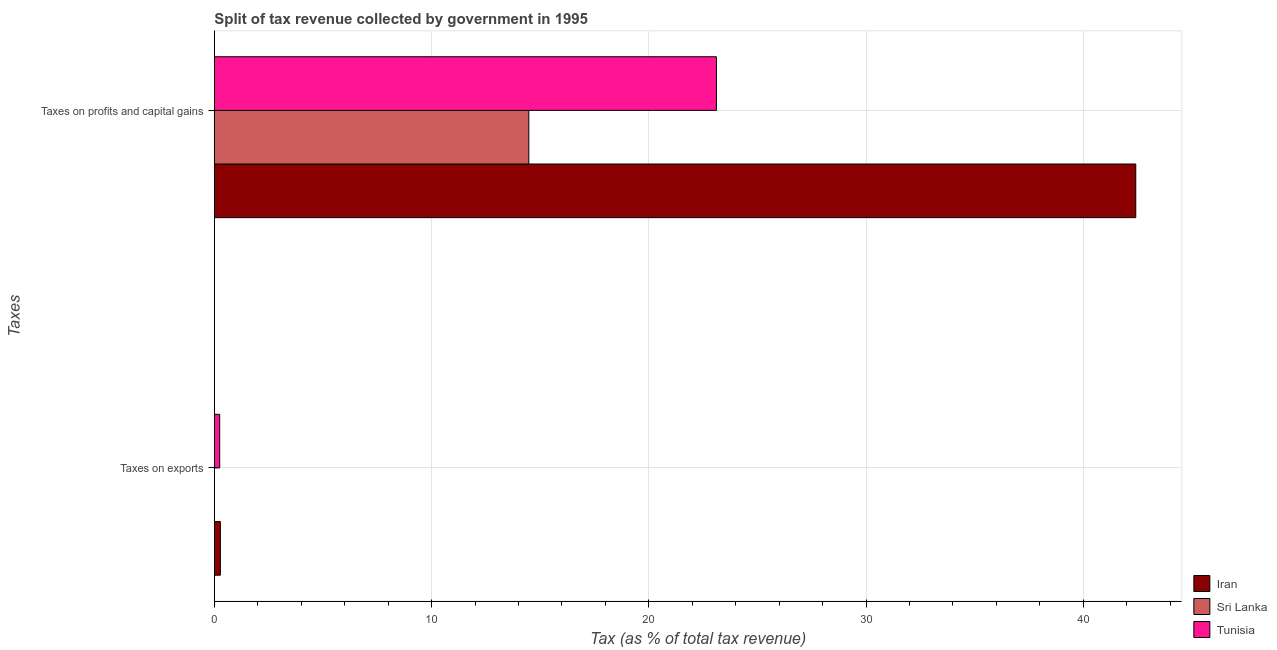Are the number of bars on each tick of the Y-axis equal?
Your answer should be very brief. Yes. How many bars are there on the 1st tick from the bottom?
Your answer should be compact. 3. What is the label of the 1st group of bars from the top?
Provide a succinct answer. Taxes on profits and capital gains. What is the percentage of revenue obtained from taxes on exports in Iran?
Your response must be concise. 0.28. Across all countries, what is the maximum percentage of revenue obtained from taxes on profits and capital gains?
Your answer should be compact. 42.42. Across all countries, what is the minimum percentage of revenue obtained from taxes on profits and capital gains?
Keep it short and to the point. 14.48. In which country was the percentage of revenue obtained from taxes on exports maximum?
Make the answer very short. Iran. In which country was the percentage of revenue obtained from taxes on profits and capital gains minimum?
Ensure brevity in your answer.  Sri Lanka. What is the total percentage of revenue obtained from taxes on exports in the graph?
Make the answer very short. 0.53. What is the difference between the percentage of revenue obtained from taxes on exports in Iran and that in Tunisia?
Make the answer very short. 0.03. What is the difference between the percentage of revenue obtained from taxes on profits and capital gains in Sri Lanka and the percentage of revenue obtained from taxes on exports in Tunisia?
Your answer should be compact. 14.23. What is the average percentage of revenue obtained from taxes on exports per country?
Keep it short and to the point. 0.18. What is the difference between the percentage of revenue obtained from taxes on profits and capital gains and percentage of revenue obtained from taxes on exports in Iran?
Ensure brevity in your answer.  42.14. What is the ratio of the percentage of revenue obtained from taxes on profits and capital gains in Tunisia to that in Sri Lanka?
Your answer should be compact. 1.6. In how many countries, is the percentage of revenue obtained from taxes on profits and capital gains greater than the average percentage of revenue obtained from taxes on profits and capital gains taken over all countries?
Offer a terse response. 1. What does the 3rd bar from the top in Taxes on profits and capital gains represents?
Provide a succinct answer. Iran. What does the 2nd bar from the bottom in Taxes on profits and capital gains represents?
Give a very brief answer. Sri Lanka. How many bars are there?
Give a very brief answer. 6. How many countries are there in the graph?
Provide a succinct answer. 3. Are the values on the major ticks of X-axis written in scientific E-notation?
Give a very brief answer. No. Does the graph contain any zero values?
Keep it short and to the point. No. Does the graph contain grids?
Give a very brief answer. Yes. How many legend labels are there?
Keep it short and to the point. 3. What is the title of the graph?
Provide a succinct answer. Split of tax revenue collected by government in 1995. Does "Heavily indebted poor countries" appear as one of the legend labels in the graph?
Your response must be concise. No. What is the label or title of the X-axis?
Give a very brief answer. Tax (as % of total tax revenue). What is the label or title of the Y-axis?
Keep it short and to the point. Taxes. What is the Tax (as % of total tax revenue) of Iran in Taxes on exports?
Your response must be concise. 0.28. What is the Tax (as % of total tax revenue) of Sri Lanka in Taxes on exports?
Keep it short and to the point. 0.01. What is the Tax (as % of total tax revenue) of Tunisia in Taxes on exports?
Make the answer very short. 0.25. What is the Tax (as % of total tax revenue) of Iran in Taxes on profits and capital gains?
Provide a short and direct response. 42.42. What is the Tax (as % of total tax revenue) of Sri Lanka in Taxes on profits and capital gains?
Offer a very short reply. 14.48. What is the Tax (as % of total tax revenue) in Tunisia in Taxes on profits and capital gains?
Provide a succinct answer. 23.11. Across all Taxes, what is the maximum Tax (as % of total tax revenue) of Iran?
Offer a terse response. 42.42. Across all Taxes, what is the maximum Tax (as % of total tax revenue) of Sri Lanka?
Give a very brief answer. 14.48. Across all Taxes, what is the maximum Tax (as % of total tax revenue) of Tunisia?
Your answer should be very brief. 23.11. Across all Taxes, what is the minimum Tax (as % of total tax revenue) of Iran?
Provide a short and direct response. 0.28. Across all Taxes, what is the minimum Tax (as % of total tax revenue) in Sri Lanka?
Offer a terse response. 0.01. Across all Taxes, what is the minimum Tax (as % of total tax revenue) in Tunisia?
Your answer should be very brief. 0.25. What is the total Tax (as % of total tax revenue) of Iran in the graph?
Give a very brief answer. 42.69. What is the total Tax (as % of total tax revenue) of Sri Lanka in the graph?
Provide a short and direct response. 14.48. What is the total Tax (as % of total tax revenue) in Tunisia in the graph?
Your answer should be very brief. 23.36. What is the difference between the Tax (as % of total tax revenue) in Iran in Taxes on exports and that in Taxes on profits and capital gains?
Your response must be concise. -42.14. What is the difference between the Tax (as % of total tax revenue) of Sri Lanka in Taxes on exports and that in Taxes on profits and capital gains?
Ensure brevity in your answer.  -14.47. What is the difference between the Tax (as % of total tax revenue) in Tunisia in Taxes on exports and that in Taxes on profits and capital gains?
Provide a short and direct response. -22.87. What is the difference between the Tax (as % of total tax revenue) of Iran in Taxes on exports and the Tax (as % of total tax revenue) of Sri Lanka in Taxes on profits and capital gains?
Provide a short and direct response. -14.2. What is the difference between the Tax (as % of total tax revenue) in Iran in Taxes on exports and the Tax (as % of total tax revenue) in Tunisia in Taxes on profits and capital gains?
Your answer should be compact. -22.84. What is the difference between the Tax (as % of total tax revenue) in Sri Lanka in Taxes on exports and the Tax (as % of total tax revenue) in Tunisia in Taxes on profits and capital gains?
Keep it short and to the point. -23.11. What is the average Tax (as % of total tax revenue) in Iran per Taxes?
Your answer should be very brief. 21.35. What is the average Tax (as % of total tax revenue) of Sri Lanka per Taxes?
Ensure brevity in your answer.  7.24. What is the average Tax (as % of total tax revenue) of Tunisia per Taxes?
Your answer should be very brief. 11.68. What is the difference between the Tax (as % of total tax revenue) of Iran and Tax (as % of total tax revenue) of Sri Lanka in Taxes on exports?
Give a very brief answer. 0.27. What is the difference between the Tax (as % of total tax revenue) in Iran and Tax (as % of total tax revenue) in Tunisia in Taxes on exports?
Provide a short and direct response. 0.03. What is the difference between the Tax (as % of total tax revenue) in Sri Lanka and Tax (as % of total tax revenue) in Tunisia in Taxes on exports?
Give a very brief answer. -0.24. What is the difference between the Tax (as % of total tax revenue) of Iran and Tax (as % of total tax revenue) of Sri Lanka in Taxes on profits and capital gains?
Give a very brief answer. 27.94. What is the difference between the Tax (as % of total tax revenue) in Iran and Tax (as % of total tax revenue) in Tunisia in Taxes on profits and capital gains?
Ensure brevity in your answer.  19.3. What is the difference between the Tax (as % of total tax revenue) in Sri Lanka and Tax (as % of total tax revenue) in Tunisia in Taxes on profits and capital gains?
Provide a succinct answer. -8.64. What is the ratio of the Tax (as % of total tax revenue) in Iran in Taxes on exports to that in Taxes on profits and capital gains?
Your answer should be very brief. 0.01. What is the ratio of the Tax (as % of total tax revenue) in Tunisia in Taxes on exports to that in Taxes on profits and capital gains?
Give a very brief answer. 0.01. What is the difference between the highest and the second highest Tax (as % of total tax revenue) in Iran?
Make the answer very short. 42.14. What is the difference between the highest and the second highest Tax (as % of total tax revenue) of Sri Lanka?
Your answer should be compact. 14.47. What is the difference between the highest and the second highest Tax (as % of total tax revenue) in Tunisia?
Your answer should be compact. 22.87. What is the difference between the highest and the lowest Tax (as % of total tax revenue) of Iran?
Keep it short and to the point. 42.14. What is the difference between the highest and the lowest Tax (as % of total tax revenue) in Sri Lanka?
Your response must be concise. 14.47. What is the difference between the highest and the lowest Tax (as % of total tax revenue) of Tunisia?
Provide a succinct answer. 22.87. 